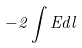Convert formula to latex. <formula><loc_0><loc_0><loc_500><loc_500>- 2 \int E d l</formula> 